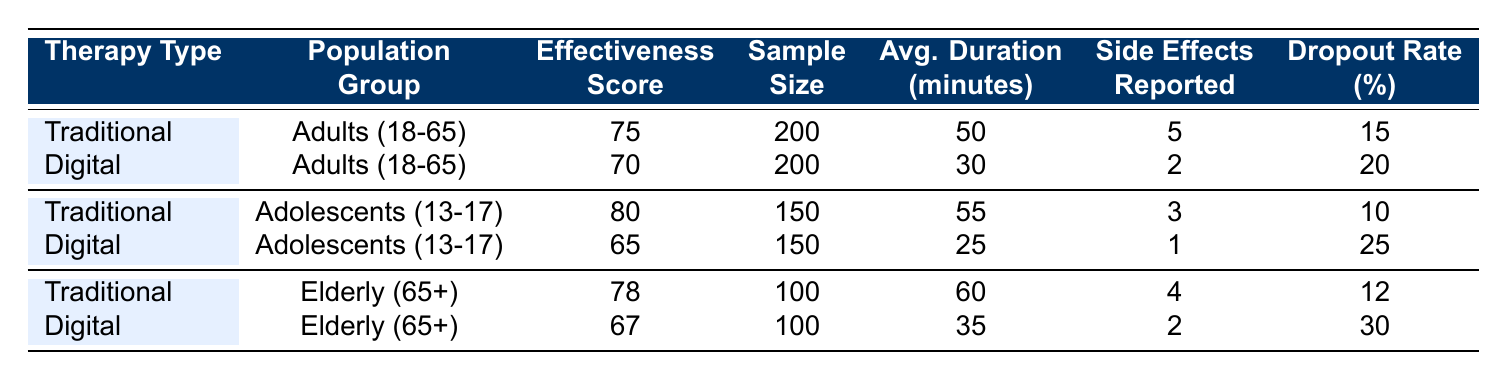What is the effectiveness score for Digital therapy among the Elderly (65+) population group? The effectiveness score for Digital therapy in the Elderly (65+) population group is listed in the table under that specific category, which shows a score of 67.
Answer: 67 Which therapy type has a lower dropout rate in Adults (18-65)? Looking at the dropout rates in the table, Traditional therapy has a dropout rate of 15%, while Digital therapy has a rate of 20%. Since 15% is less than 20%, Traditional therapy has the lower dropout rate for this age group.
Answer: Traditional What is the average session duration for Traditional therapy in Adolescents (13-17)? The table indicates that the average session duration for Traditional therapy in the Adolescents (13-17) group is 55 minutes as recorded directly in the relevant row of the table.
Answer: 55 What is the difference between the effectiveness scores of Traditional therapy for Adolescents (13-17) and Digital therapy for the same group? The effectiveness score for Traditional therapy in Adolescents is 80, and for Digital therapy, it is 65. To find the difference, we subtract: 80 - 65 = 15. Therefore, the difference between their scores is 15 points.
Answer: 15 Does the Digital therapy show a higher effectiveness score for any population group compared to Traditional therapy? The table indicates that in each population group, the effectiveness score for Traditional therapy is higher than that of Digital therapy. Hence, the answer is no; there is no population group where Digital therapy exceeds the effectiveness score of Traditional therapy.
Answer: No What is the average number of reported side effects for Digital therapy across all populations? To find the average side effects for Digital therapy, we sum the reported side effects: 2 (Adults) + 1 (Adolescents) + 2 (Elderly) = 5. Then, we divide by the number of groups (3): 5 / 3 ≈ 1.67. Thus, the average number of side effects is approximately 1.67.
Answer: 1.67 Which population group shows the lowest effectiveness score for Digital therapy? The table shows that Digital therapy effectiveness scores are 70 for Adults, 65 for Adolescents, and 67 for Elderly. Among these, Adolescents (13-17) have the lowest score of 65.
Answer: Adolescents (13-17) What is the reported side effects count for Traditional therapy in the Elderly (65+) compared to the score for Digital therapy in that group? The reported side effects for Traditional therapy among the Elderly is 4, while for Digital therapy in the same group, it is 2. Comparing these values, Traditional therapy has a higher reported side effects count than Digital therapy, showing 4 versus 2.
Answer: Traditional therapy has higher side effects 